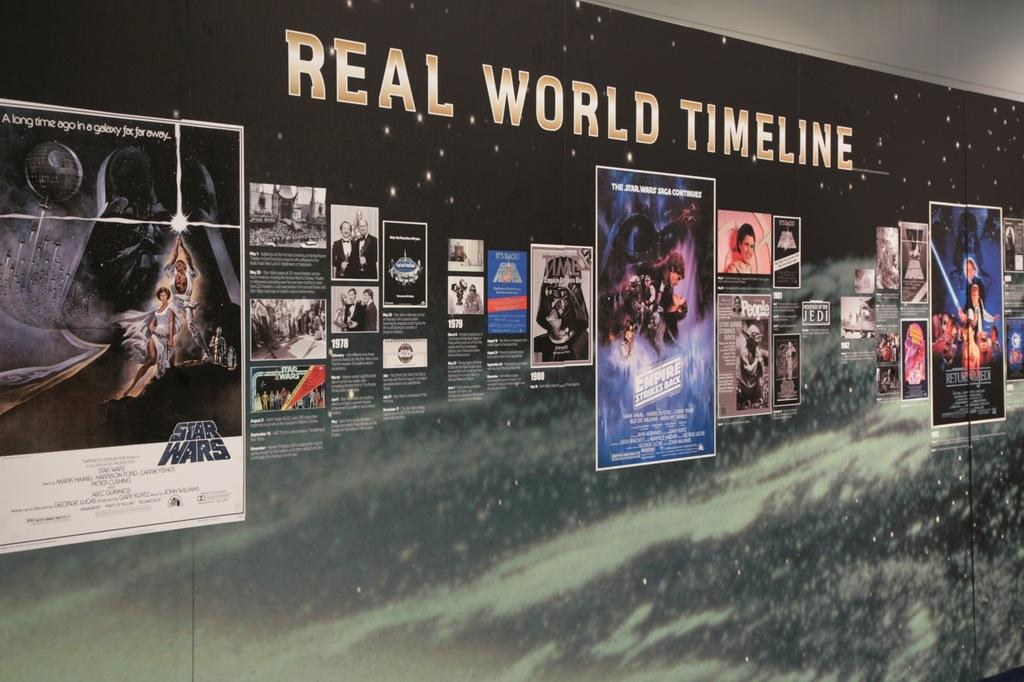<image>
Summarize the visual content of the image. Wall full of pictures and the words "Real World Timeline" above it. 